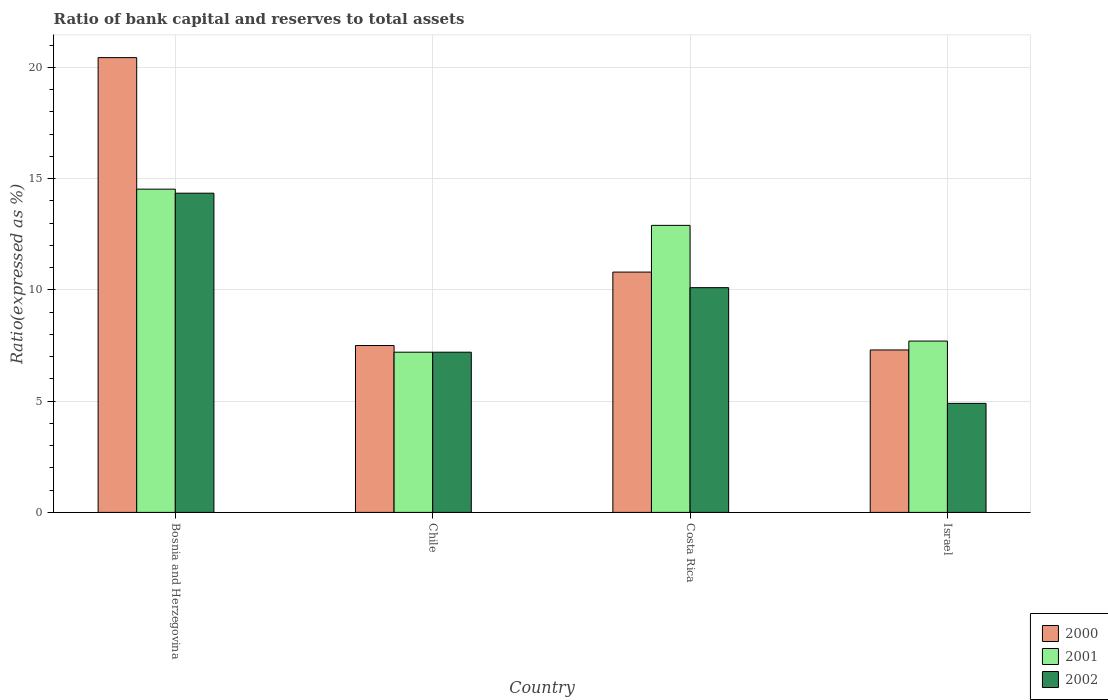Are the number of bars per tick equal to the number of legend labels?
Provide a succinct answer. Yes. In how many cases, is the number of bars for a given country not equal to the number of legend labels?
Keep it short and to the point. 0. Across all countries, what is the maximum ratio of bank capital and reserves to total assets in 2001?
Give a very brief answer. 14.53. Across all countries, what is the minimum ratio of bank capital and reserves to total assets in 2001?
Ensure brevity in your answer.  7.2. In which country was the ratio of bank capital and reserves to total assets in 2000 maximum?
Your answer should be compact. Bosnia and Herzegovina. What is the total ratio of bank capital and reserves to total assets in 2001 in the graph?
Provide a succinct answer. 42.33. What is the difference between the ratio of bank capital and reserves to total assets in 2000 in Bosnia and Herzegovina and that in Chile?
Make the answer very short. 12.94. What is the difference between the ratio of bank capital and reserves to total assets in 2000 in Bosnia and Herzegovina and the ratio of bank capital and reserves to total assets in 2001 in Chile?
Give a very brief answer. 13.24. What is the average ratio of bank capital and reserves to total assets in 2001 per country?
Make the answer very short. 10.58. What is the difference between the ratio of bank capital and reserves to total assets of/in 2000 and ratio of bank capital and reserves to total assets of/in 2001 in Israel?
Your response must be concise. -0.4. What is the ratio of the ratio of bank capital and reserves to total assets in 2001 in Bosnia and Herzegovina to that in Israel?
Make the answer very short. 1.89. Is the ratio of bank capital and reserves to total assets in 2001 in Costa Rica less than that in Israel?
Give a very brief answer. No. Is the difference between the ratio of bank capital and reserves to total assets in 2000 in Bosnia and Herzegovina and Chile greater than the difference between the ratio of bank capital and reserves to total assets in 2001 in Bosnia and Herzegovina and Chile?
Keep it short and to the point. Yes. What is the difference between the highest and the second highest ratio of bank capital and reserves to total assets in 2002?
Provide a short and direct response. -4.25. What is the difference between the highest and the lowest ratio of bank capital and reserves to total assets in 2000?
Ensure brevity in your answer.  13.14. In how many countries, is the ratio of bank capital and reserves to total assets in 2000 greater than the average ratio of bank capital and reserves to total assets in 2000 taken over all countries?
Your response must be concise. 1. How many countries are there in the graph?
Your response must be concise. 4. Does the graph contain any zero values?
Offer a very short reply. No. How many legend labels are there?
Give a very brief answer. 3. How are the legend labels stacked?
Your response must be concise. Vertical. What is the title of the graph?
Ensure brevity in your answer.  Ratio of bank capital and reserves to total assets. What is the label or title of the X-axis?
Your answer should be very brief. Country. What is the label or title of the Y-axis?
Ensure brevity in your answer.  Ratio(expressed as %). What is the Ratio(expressed as %) of 2000 in Bosnia and Herzegovina?
Your response must be concise. 20.44. What is the Ratio(expressed as %) in 2001 in Bosnia and Herzegovina?
Provide a short and direct response. 14.53. What is the Ratio(expressed as %) in 2002 in Bosnia and Herzegovina?
Your answer should be very brief. 14.35. What is the Ratio(expressed as %) in 2000 in Chile?
Your answer should be compact. 7.5. What is the Ratio(expressed as %) of 2001 in Chile?
Offer a terse response. 7.2. What is the Ratio(expressed as %) in 2002 in Chile?
Your answer should be very brief. 7.2. What is the Ratio(expressed as %) in 2000 in Costa Rica?
Your answer should be very brief. 10.8. What is the Ratio(expressed as %) in 2002 in Costa Rica?
Ensure brevity in your answer.  10.1. What is the Ratio(expressed as %) of 2000 in Israel?
Your response must be concise. 7.3. What is the Ratio(expressed as %) in 2002 in Israel?
Ensure brevity in your answer.  4.9. Across all countries, what is the maximum Ratio(expressed as %) in 2000?
Offer a terse response. 20.44. Across all countries, what is the maximum Ratio(expressed as %) in 2001?
Your answer should be compact. 14.53. Across all countries, what is the maximum Ratio(expressed as %) in 2002?
Ensure brevity in your answer.  14.35. Across all countries, what is the minimum Ratio(expressed as %) of 2000?
Your answer should be compact. 7.3. Across all countries, what is the minimum Ratio(expressed as %) of 2002?
Provide a short and direct response. 4.9. What is the total Ratio(expressed as %) in 2000 in the graph?
Provide a short and direct response. 46.04. What is the total Ratio(expressed as %) in 2001 in the graph?
Provide a short and direct response. 42.33. What is the total Ratio(expressed as %) in 2002 in the graph?
Provide a short and direct response. 36.55. What is the difference between the Ratio(expressed as %) in 2000 in Bosnia and Herzegovina and that in Chile?
Your answer should be very brief. 12.94. What is the difference between the Ratio(expressed as %) of 2001 in Bosnia and Herzegovina and that in Chile?
Your answer should be very brief. 7.33. What is the difference between the Ratio(expressed as %) of 2002 in Bosnia and Herzegovina and that in Chile?
Provide a short and direct response. 7.15. What is the difference between the Ratio(expressed as %) of 2000 in Bosnia and Herzegovina and that in Costa Rica?
Keep it short and to the point. 9.64. What is the difference between the Ratio(expressed as %) in 2001 in Bosnia and Herzegovina and that in Costa Rica?
Ensure brevity in your answer.  1.63. What is the difference between the Ratio(expressed as %) of 2002 in Bosnia and Herzegovina and that in Costa Rica?
Offer a terse response. 4.25. What is the difference between the Ratio(expressed as %) in 2000 in Bosnia and Herzegovina and that in Israel?
Make the answer very short. 13.14. What is the difference between the Ratio(expressed as %) of 2001 in Bosnia and Herzegovina and that in Israel?
Make the answer very short. 6.83. What is the difference between the Ratio(expressed as %) in 2002 in Bosnia and Herzegovina and that in Israel?
Make the answer very short. 9.45. What is the difference between the Ratio(expressed as %) in 2000 in Chile and that in Costa Rica?
Ensure brevity in your answer.  -3.3. What is the difference between the Ratio(expressed as %) of 2001 in Chile and that in Costa Rica?
Offer a very short reply. -5.7. What is the difference between the Ratio(expressed as %) of 2002 in Chile and that in Costa Rica?
Offer a very short reply. -2.9. What is the difference between the Ratio(expressed as %) in 2002 in Chile and that in Israel?
Your answer should be compact. 2.3. What is the difference between the Ratio(expressed as %) in 2000 in Costa Rica and that in Israel?
Provide a succinct answer. 3.5. What is the difference between the Ratio(expressed as %) in 2002 in Costa Rica and that in Israel?
Offer a terse response. 5.2. What is the difference between the Ratio(expressed as %) in 2000 in Bosnia and Herzegovina and the Ratio(expressed as %) in 2001 in Chile?
Provide a succinct answer. 13.24. What is the difference between the Ratio(expressed as %) of 2000 in Bosnia and Herzegovina and the Ratio(expressed as %) of 2002 in Chile?
Provide a short and direct response. 13.24. What is the difference between the Ratio(expressed as %) of 2001 in Bosnia and Herzegovina and the Ratio(expressed as %) of 2002 in Chile?
Make the answer very short. 7.33. What is the difference between the Ratio(expressed as %) in 2000 in Bosnia and Herzegovina and the Ratio(expressed as %) in 2001 in Costa Rica?
Ensure brevity in your answer.  7.54. What is the difference between the Ratio(expressed as %) of 2000 in Bosnia and Herzegovina and the Ratio(expressed as %) of 2002 in Costa Rica?
Offer a terse response. 10.34. What is the difference between the Ratio(expressed as %) of 2001 in Bosnia and Herzegovina and the Ratio(expressed as %) of 2002 in Costa Rica?
Offer a very short reply. 4.43. What is the difference between the Ratio(expressed as %) in 2000 in Bosnia and Herzegovina and the Ratio(expressed as %) in 2001 in Israel?
Give a very brief answer. 12.74. What is the difference between the Ratio(expressed as %) in 2000 in Bosnia and Herzegovina and the Ratio(expressed as %) in 2002 in Israel?
Offer a terse response. 15.54. What is the difference between the Ratio(expressed as %) of 2001 in Bosnia and Herzegovina and the Ratio(expressed as %) of 2002 in Israel?
Provide a succinct answer. 9.63. What is the difference between the Ratio(expressed as %) in 2000 in Chile and the Ratio(expressed as %) in 2002 in Costa Rica?
Offer a very short reply. -2.6. What is the difference between the Ratio(expressed as %) of 2000 in Chile and the Ratio(expressed as %) of 2002 in Israel?
Your answer should be compact. 2.6. What is the difference between the Ratio(expressed as %) in 2001 in Chile and the Ratio(expressed as %) in 2002 in Israel?
Offer a terse response. 2.3. What is the difference between the Ratio(expressed as %) of 2000 in Costa Rica and the Ratio(expressed as %) of 2001 in Israel?
Provide a short and direct response. 3.1. What is the difference between the Ratio(expressed as %) of 2000 in Costa Rica and the Ratio(expressed as %) of 2002 in Israel?
Give a very brief answer. 5.9. What is the difference between the Ratio(expressed as %) in 2001 in Costa Rica and the Ratio(expressed as %) in 2002 in Israel?
Your answer should be very brief. 8. What is the average Ratio(expressed as %) in 2000 per country?
Provide a succinct answer. 11.51. What is the average Ratio(expressed as %) of 2001 per country?
Keep it short and to the point. 10.58. What is the average Ratio(expressed as %) in 2002 per country?
Your response must be concise. 9.14. What is the difference between the Ratio(expressed as %) of 2000 and Ratio(expressed as %) of 2001 in Bosnia and Herzegovina?
Provide a succinct answer. 5.91. What is the difference between the Ratio(expressed as %) in 2000 and Ratio(expressed as %) in 2002 in Bosnia and Herzegovina?
Your response must be concise. 6.09. What is the difference between the Ratio(expressed as %) in 2001 and Ratio(expressed as %) in 2002 in Bosnia and Herzegovina?
Give a very brief answer. 0.18. What is the difference between the Ratio(expressed as %) of 2000 and Ratio(expressed as %) of 2002 in Costa Rica?
Make the answer very short. 0.7. What is the difference between the Ratio(expressed as %) of 2000 and Ratio(expressed as %) of 2002 in Israel?
Provide a succinct answer. 2.4. What is the difference between the Ratio(expressed as %) in 2001 and Ratio(expressed as %) in 2002 in Israel?
Give a very brief answer. 2.8. What is the ratio of the Ratio(expressed as %) in 2000 in Bosnia and Herzegovina to that in Chile?
Ensure brevity in your answer.  2.73. What is the ratio of the Ratio(expressed as %) in 2001 in Bosnia and Herzegovina to that in Chile?
Your answer should be compact. 2.02. What is the ratio of the Ratio(expressed as %) of 2002 in Bosnia and Herzegovina to that in Chile?
Offer a very short reply. 1.99. What is the ratio of the Ratio(expressed as %) of 2000 in Bosnia and Herzegovina to that in Costa Rica?
Keep it short and to the point. 1.89. What is the ratio of the Ratio(expressed as %) of 2001 in Bosnia and Herzegovina to that in Costa Rica?
Offer a terse response. 1.13. What is the ratio of the Ratio(expressed as %) of 2002 in Bosnia and Herzegovina to that in Costa Rica?
Provide a short and direct response. 1.42. What is the ratio of the Ratio(expressed as %) in 2000 in Bosnia and Herzegovina to that in Israel?
Provide a short and direct response. 2.8. What is the ratio of the Ratio(expressed as %) of 2001 in Bosnia and Herzegovina to that in Israel?
Provide a succinct answer. 1.89. What is the ratio of the Ratio(expressed as %) of 2002 in Bosnia and Herzegovina to that in Israel?
Your answer should be very brief. 2.93. What is the ratio of the Ratio(expressed as %) in 2000 in Chile to that in Costa Rica?
Provide a short and direct response. 0.69. What is the ratio of the Ratio(expressed as %) in 2001 in Chile to that in Costa Rica?
Keep it short and to the point. 0.56. What is the ratio of the Ratio(expressed as %) of 2002 in Chile to that in Costa Rica?
Your answer should be compact. 0.71. What is the ratio of the Ratio(expressed as %) in 2000 in Chile to that in Israel?
Make the answer very short. 1.03. What is the ratio of the Ratio(expressed as %) in 2001 in Chile to that in Israel?
Offer a terse response. 0.94. What is the ratio of the Ratio(expressed as %) of 2002 in Chile to that in Israel?
Your answer should be very brief. 1.47. What is the ratio of the Ratio(expressed as %) in 2000 in Costa Rica to that in Israel?
Your response must be concise. 1.48. What is the ratio of the Ratio(expressed as %) in 2001 in Costa Rica to that in Israel?
Make the answer very short. 1.68. What is the ratio of the Ratio(expressed as %) of 2002 in Costa Rica to that in Israel?
Offer a very short reply. 2.06. What is the difference between the highest and the second highest Ratio(expressed as %) of 2000?
Offer a terse response. 9.64. What is the difference between the highest and the second highest Ratio(expressed as %) of 2001?
Your answer should be very brief. 1.63. What is the difference between the highest and the second highest Ratio(expressed as %) of 2002?
Offer a very short reply. 4.25. What is the difference between the highest and the lowest Ratio(expressed as %) in 2000?
Ensure brevity in your answer.  13.14. What is the difference between the highest and the lowest Ratio(expressed as %) in 2001?
Your answer should be compact. 7.33. What is the difference between the highest and the lowest Ratio(expressed as %) of 2002?
Provide a succinct answer. 9.45. 